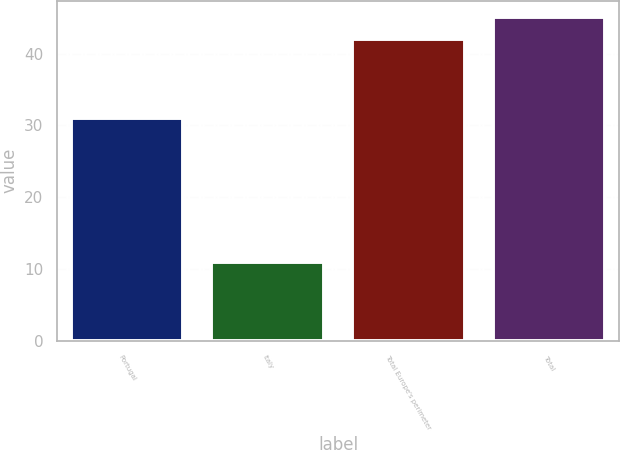<chart> <loc_0><loc_0><loc_500><loc_500><bar_chart><fcel>Portugal<fcel>Italy<fcel>Total Europe's perimeter<fcel>Total<nl><fcel>31<fcel>11<fcel>42<fcel>45.1<nl></chart> 